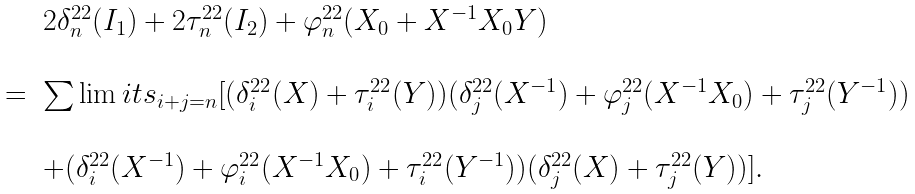Convert formula to latex. <formula><loc_0><loc_0><loc_500><loc_500>\begin{array} { r c l } & & 2 \delta _ { n } ^ { 2 2 } ( I _ { 1 } ) + 2 \tau _ { n } ^ { 2 2 } ( I _ { 2 } ) + \varphi _ { n } ^ { 2 2 } ( X _ { 0 } + X ^ { - 1 } X _ { 0 } Y ) \\ \\ & = & \sum \lim i t s _ { i + j = n } [ ( \delta _ { i } ^ { 2 2 } ( X ) + \tau _ { i } ^ { 2 2 } ( Y ) ) ( \delta _ { j } ^ { 2 2 } ( X ^ { - 1 } ) + \varphi _ { j } ^ { 2 2 } ( X ^ { - 1 } X _ { 0 } ) + \tau _ { j } ^ { 2 2 } ( Y ^ { - 1 } ) ) \\ \\ & & + ( \delta _ { i } ^ { 2 2 } ( X ^ { - 1 } ) + \varphi _ { i } ^ { 2 2 } ( X ^ { - 1 } X _ { 0 } ) + \tau _ { i } ^ { 2 2 } ( Y ^ { - 1 } ) ) ( \delta _ { j } ^ { 2 2 } ( X ) + \tau _ { j } ^ { 2 2 } ( Y ) ) ] . \end{array}</formula> 